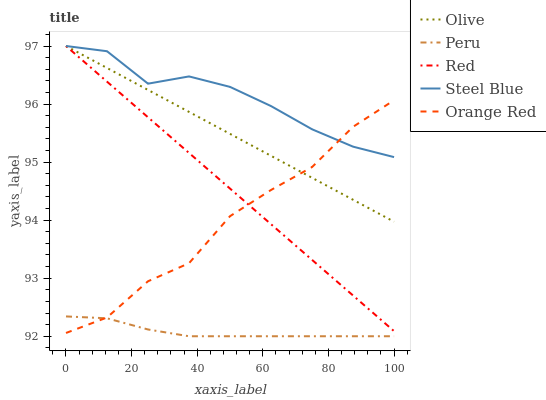Does Peru have the minimum area under the curve?
Answer yes or no. Yes. Does Steel Blue have the maximum area under the curve?
Answer yes or no. Yes. Does Orange Red have the minimum area under the curve?
Answer yes or no. No. Does Orange Red have the maximum area under the curve?
Answer yes or no. No. Is Red the smoothest?
Answer yes or no. Yes. Is Orange Red the roughest?
Answer yes or no. Yes. Is Orange Red the smoothest?
Answer yes or no. No. Is Red the roughest?
Answer yes or no. No. Does Peru have the lowest value?
Answer yes or no. Yes. Does Orange Red have the lowest value?
Answer yes or no. No. Does Steel Blue have the highest value?
Answer yes or no. Yes. Does Orange Red have the highest value?
Answer yes or no. No. Is Peru less than Red?
Answer yes or no. Yes. Is Steel Blue greater than Peru?
Answer yes or no. Yes. Does Orange Red intersect Steel Blue?
Answer yes or no. Yes. Is Orange Red less than Steel Blue?
Answer yes or no. No. Is Orange Red greater than Steel Blue?
Answer yes or no. No. Does Peru intersect Red?
Answer yes or no. No. 